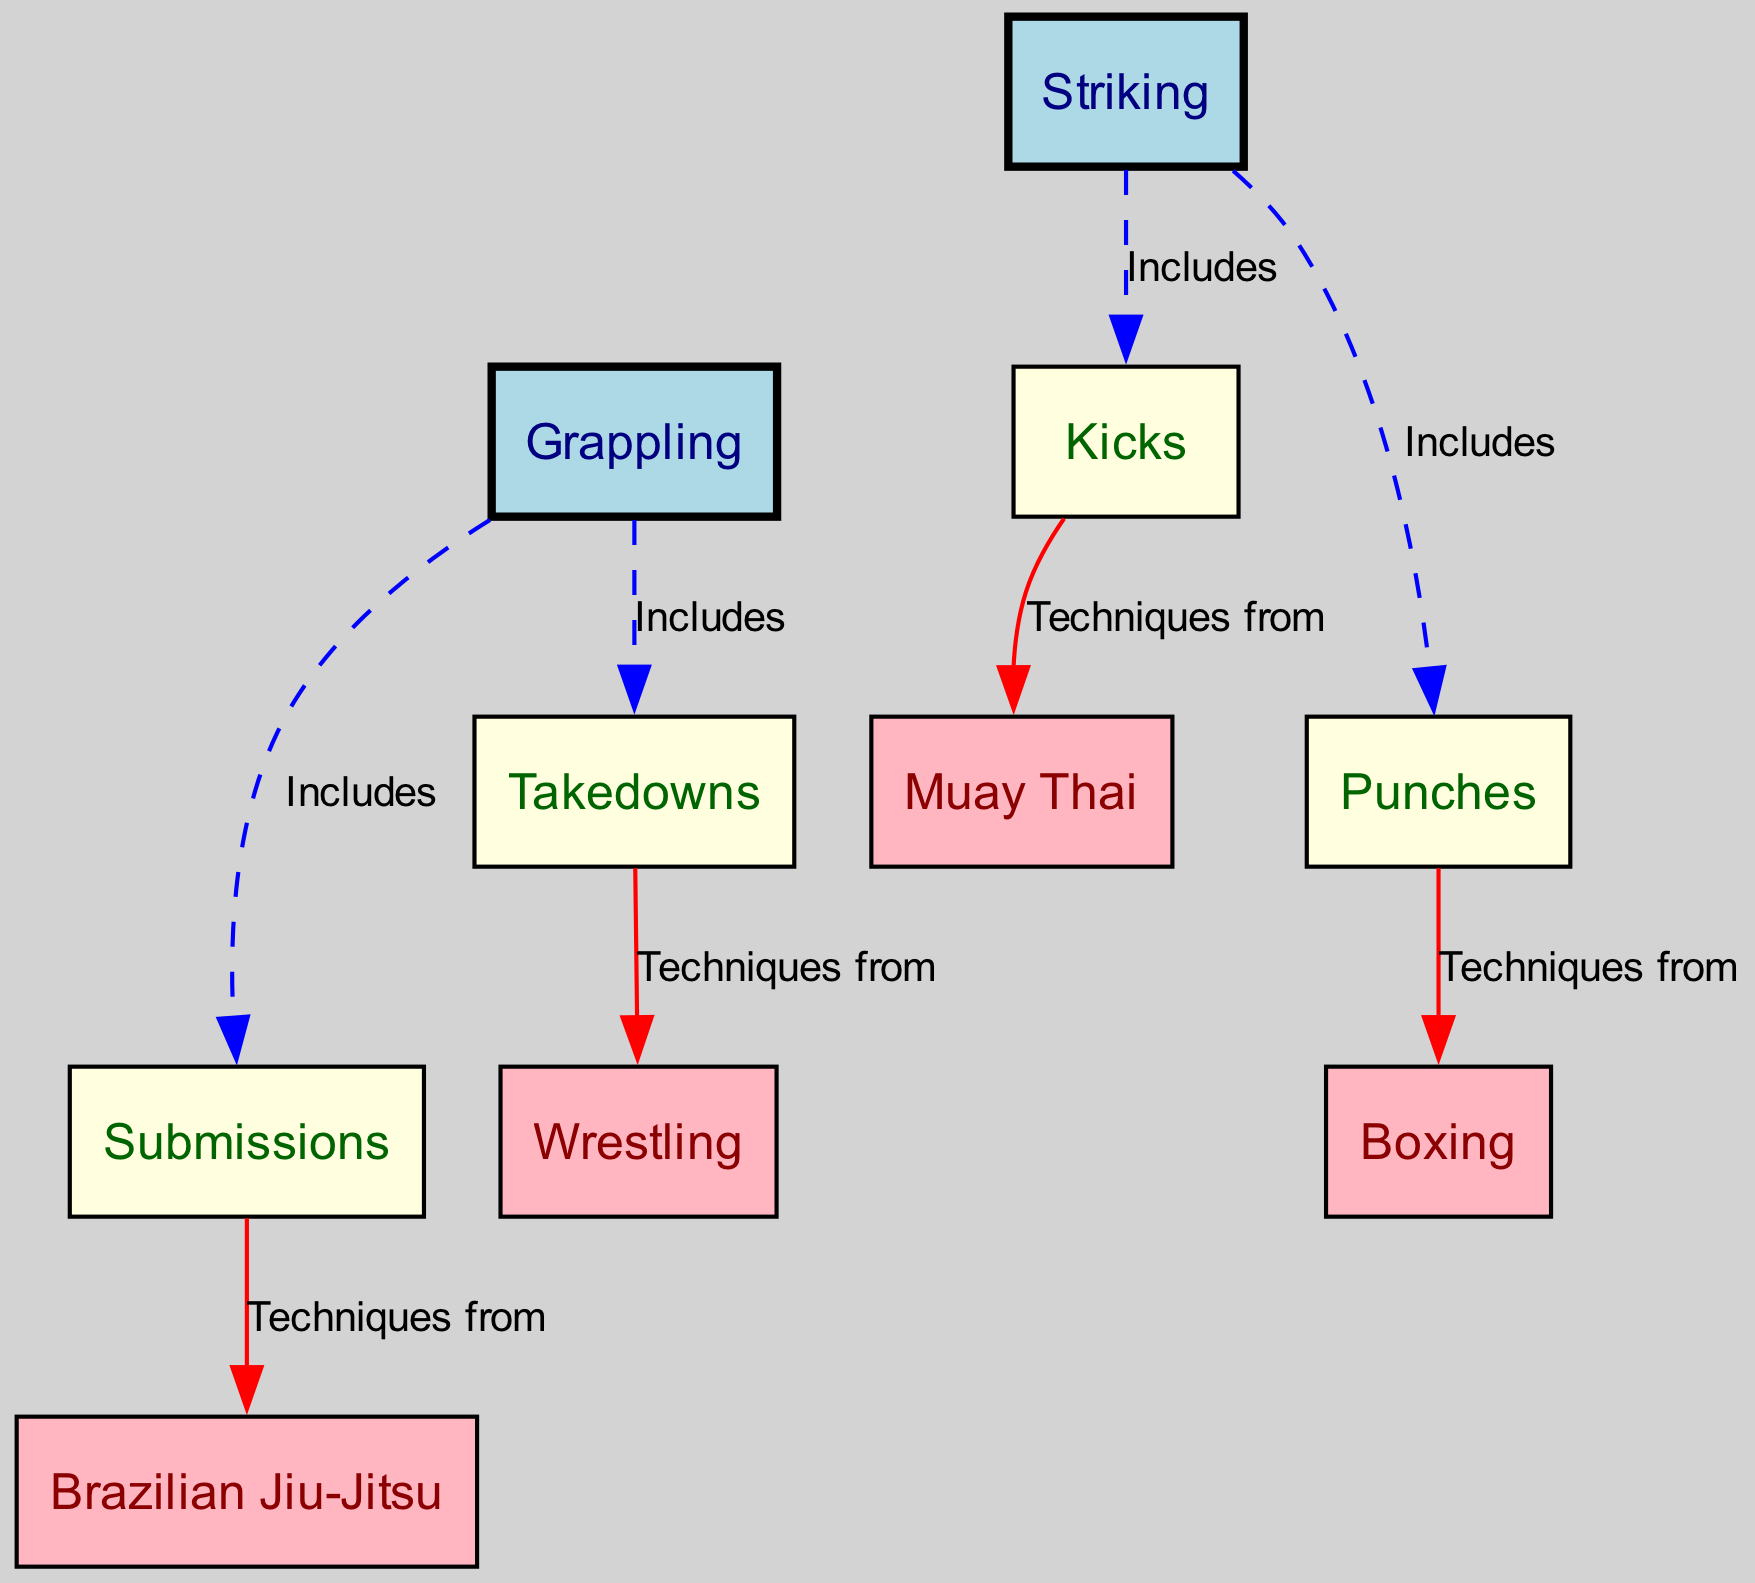What is the total number of nodes in the diagram? The diagram contains several distinct nodes. Counting each node listed in the data, there are ten nodes present: Striking, Grappling, Kicks, Punches, Takedowns, Submissions, Muay Thai, Boxing, Wrestling, and Brazilian Jiu-Jitsu.
Answer: 10 What are the techniques included under Striking? The edges in the diagram indicate the relationships between nodes. Starting from the Striking node, the techniques included are Kicks and Punches, as represented in the edges: "Includes Kicks" and "Includes Punches."
Answer: Kicks, Punches Which node has a direct connection to Submissions? By tracing the edges from Submissions, it can be seen that it is directly connected to the Brazilian Jiu-Jitsu node through the label "Techniques from". The edge indicates that Submissions are techniques derived from Brazilian Jiu-Jitsu.
Answer: Brazilian Jiu-Jitsu How many edges are labeled "Includes"? The diagram includes multiple edges with different labels. By reviewing the edge list, the edges labeled "Includes" are the following: Striking to Kicks, Striking to Punches, Grappling to Takedowns, and Grappling to Submissions. This totals four edges that are marked as "Includes."
Answer: 4 Which technique is connected to the Kicks node? Checking the outgoing connection from the Kicks node, the diagram indicates a direct connection to the Muay Thai node with the label "Techniques from." This shows that Kicks are techniques derived from Muay Thai.
Answer: Muay Thai How many types of grappling techniques are represented? Examining the connections from the Grappling node reveals two types of grappling techniques. They are Takedowns and Submissions, as indicated by the edges labeled "Includes" from the Grappling node to each technique.
Answer: 2 What color represents the primary skills of Striking and Grappling? The color scheme of the nodes is described in the diagram data. Both Striking and Grappling nodes are colored light blue, which denotes their category as primary skills in the diagram.
Answer: Light blue Which two techniques are categorized under Kicks? Looking at the Kicks node in conjunction with its outgoing connections, the diagram does not directly list specific techniques; however, it implies that the techniques should be Muay Thai since it includes Kicks. Therefore, Muay Thai is the technique categorized under Kicks.
Answer: Muay Thai How many total techniques are derived from Punches? Looking at the data related to the Punches node, there is one direct connection listed to Boxing, indicating that this is the only technique derived from Punches as represented in the diagram.
Answer: 1 